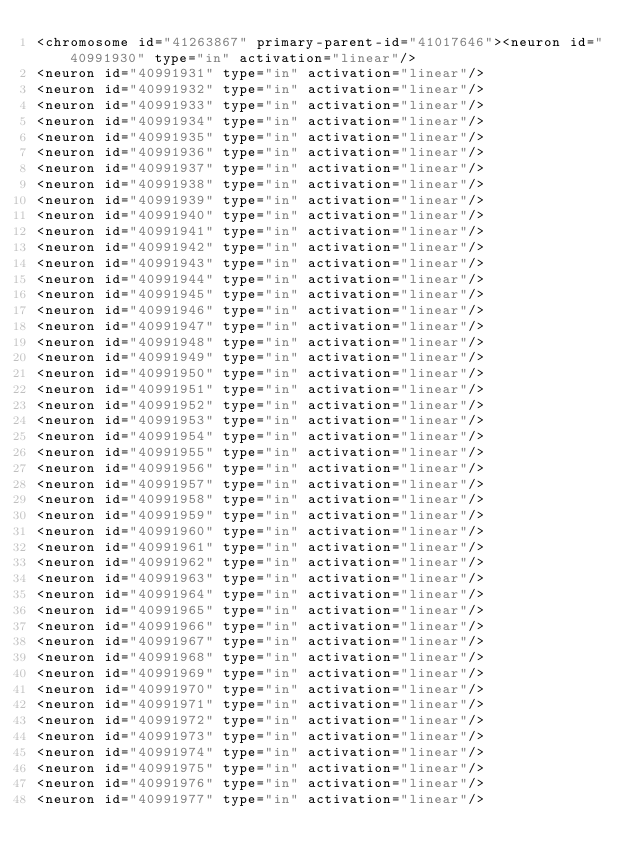<code> <loc_0><loc_0><loc_500><loc_500><_XML_><chromosome id="41263867" primary-parent-id="41017646"><neuron id="40991930" type="in" activation="linear"/>
<neuron id="40991931" type="in" activation="linear"/>
<neuron id="40991932" type="in" activation="linear"/>
<neuron id="40991933" type="in" activation="linear"/>
<neuron id="40991934" type="in" activation="linear"/>
<neuron id="40991935" type="in" activation="linear"/>
<neuron id="40991936" type="in" activation="linear"/>
<neuron id="40991937" type="in" activation="linear"/>
<neuron id="40991938" type="in" activation="linear"/>
<neuron id="40991939" type="in" activation="linear"/>
<neuron id="40991940" type="in" activation="linear"/>
<neuron id="40991941" type="in" activation="linear"/>
<neuron id="40991942" type="in" activation="linear"/>
<neuron id="40991943" type="in" activation="linear"/>
<neuron id="40991944" type="in" activation="linear"/>
<neuron id="40991945" type="in" activation="linear"/>
<neuron id="40991946" type="in" activation="linear"/>
<neuron id="40991947" type="in" activation="linear"/>
<neuron id="40991948" type="in" activation="linear"/>
<neuron id="40991949" type="in" activation="linear"/>
<neuron id="40991950" type="in" activation="linear"/>
<neuron id="40991951" type="in" activation="linear"/>
<neuron id="40991952" type="in" activation="linear"/>
<neuron id="40991953" type="in" activation="linear"/>
<neuron id="40991954" type="in" activation="linear"/>
<neuron id="40991955" type="in" activation="linear"/>
<neuron id="40991956" type="in" activation="linear"/>
<neuron id="40991957" type="in" activation="linear"/>
<neuron id="40991958" type="in" activation="linear"/>
<neuron id="40991959" type="in" activation="linear"/>
<neuron id="40991960" type="in" activation="linear"/>
<neuron id="40991961" type="in" activation="linear"/>
<neuron id="40991962" type="in" activation="linear"/>
<neuron id="40991963" type="in" activation="linear"/>
<neuron id="40991964" type="in" activation="linear"/>
<neuron id="40991965" type="in" activation="linear"/>
<neuron id="40991966" type="in" activation="linear"/>
<neuron id="40991967" type="in" activation="linear"/>
<neuron id="40991968" type="in" activation="linear"/>
<neuron id="40991969" type="in" activation="linear"/>
<neuron id="40991970" type="in" activation="linear"/>
<neuron id="40991971" type="in" activation="linear"/>
<neuron id="40991972" type="in" activation="linear"/>
<neuron id="40991973" type="in" activation="linear"/>
<neuron id="40991974" type="in" activation="linear"/>
<neuron id="40991975" type="in" activation="linear"/>
<neuron id="40991976" type="in" activation="linear"/>
<neuron id="40991977" type="in" activation="linear"/></code> 